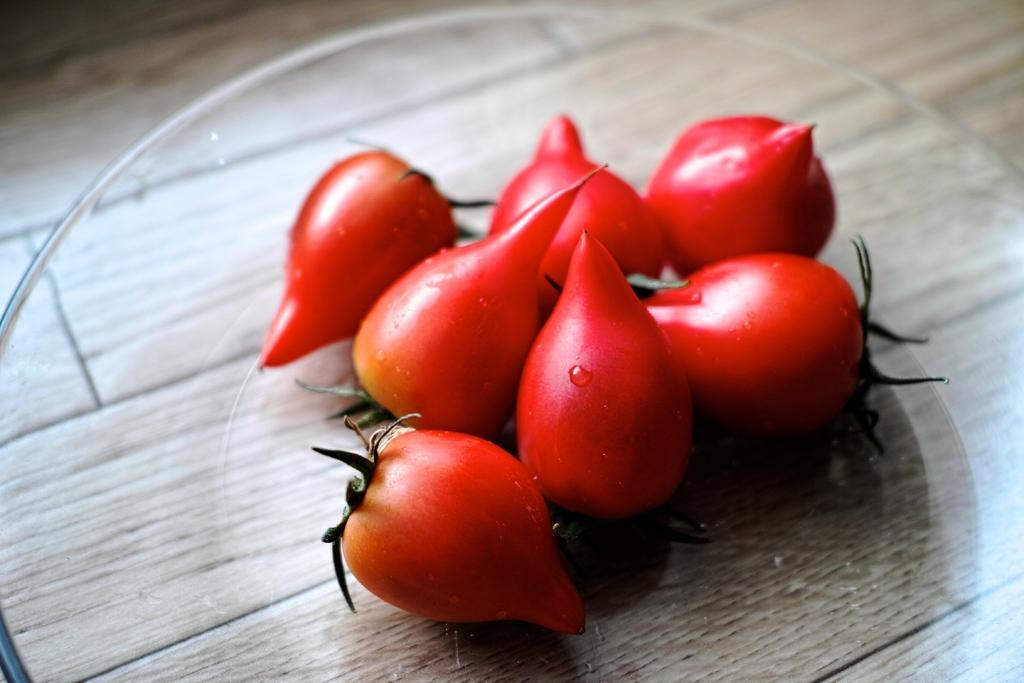What type of food is on the glass plate in the image? There are tomatoes on a glass plate in the image. What is the material of the plate holding the tomatoes? The plate is made of glass. Where is the glass plate with tomatoes located? The glass plate with tomatoes is on a surface. How many geese are standing on the floor in the image? There are no geese present in the image; it only features tomatoes on a glass plate. 